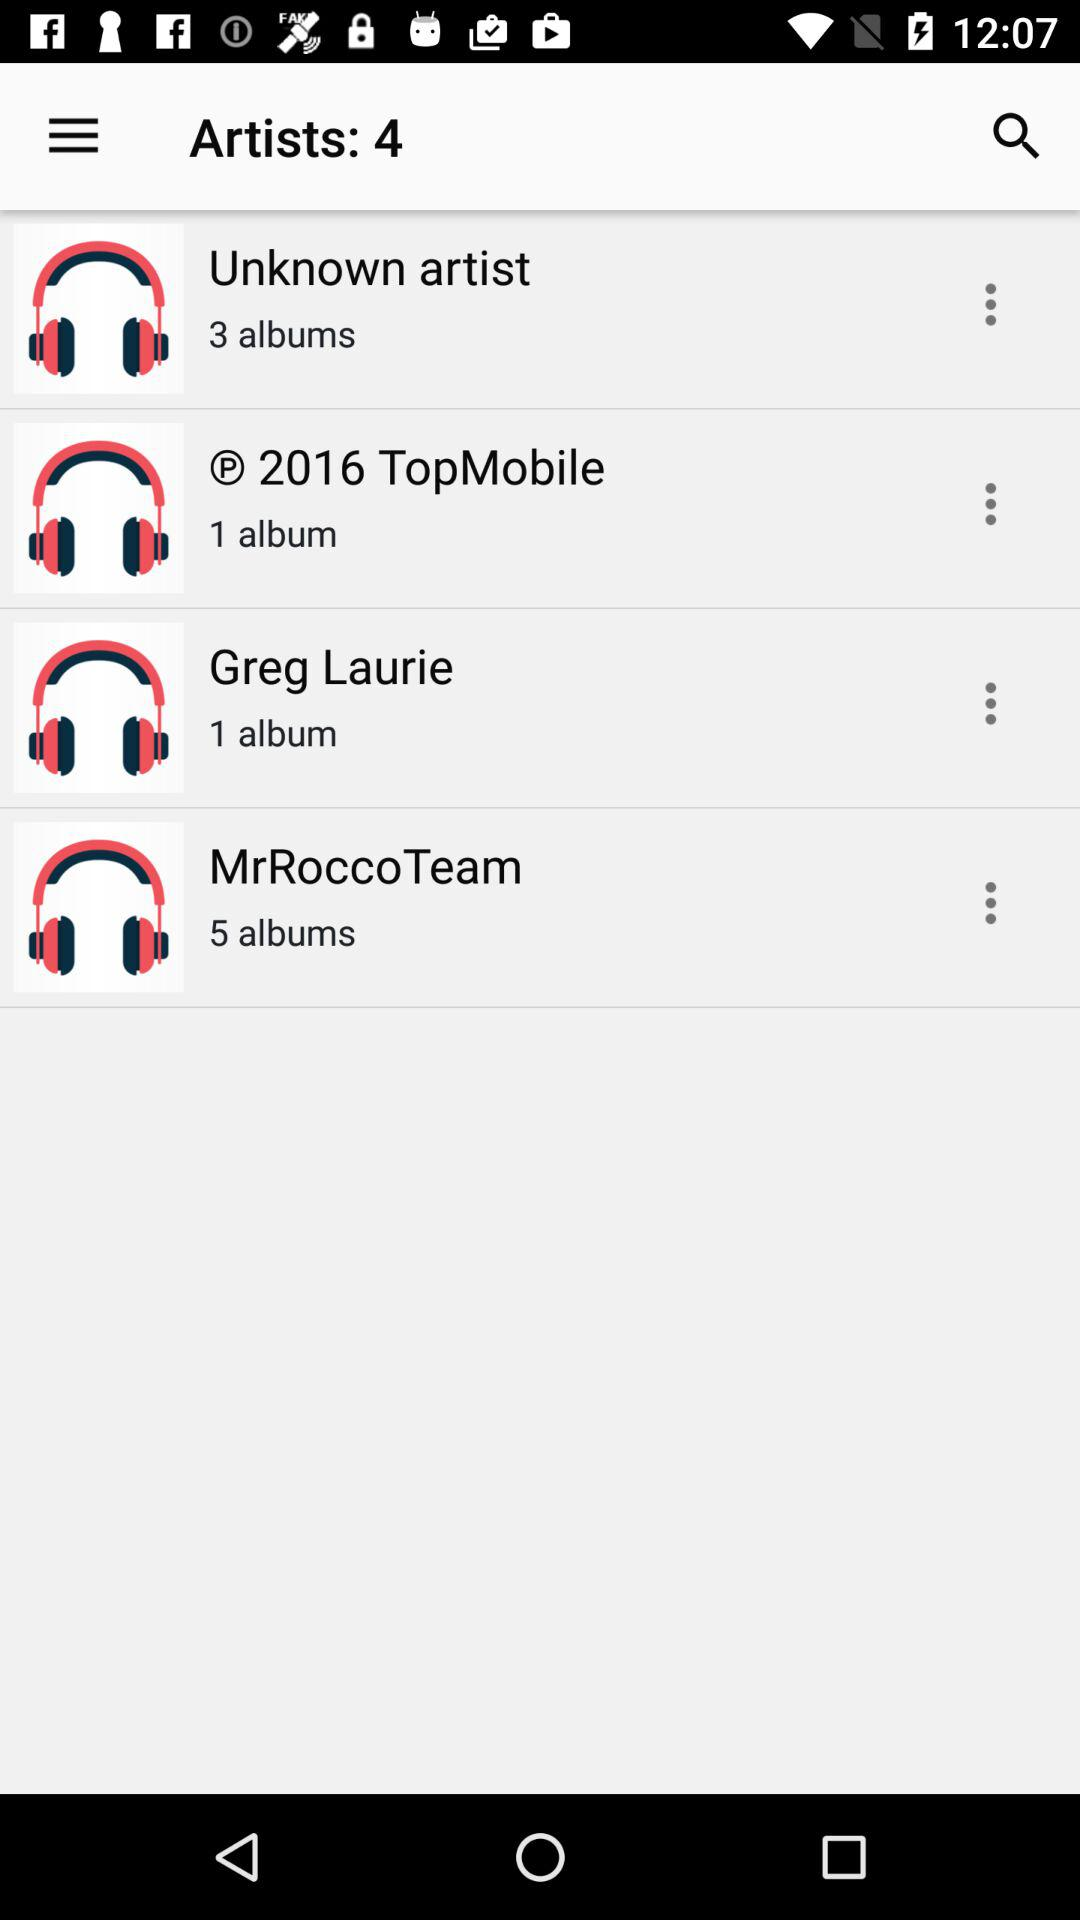How many albums does "Greg Laurie" contain? "Greg Laurie" contains 1 album. 